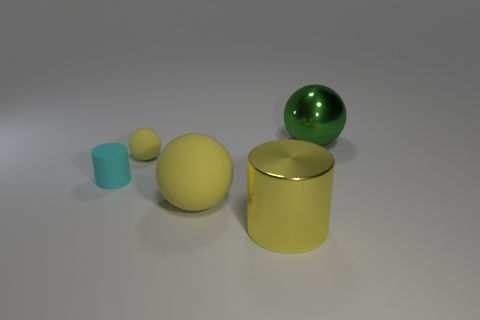Could you describe the setting or environment where these objects are placed? The objects appear to be resting on a flat, matte surface which reflects their shapes subtly, indicating it might be smooth or polished. The background is a uniform, featureless grey, suggesting this could be an indoor studio setting designed to emphasize the objects without any distractions. 